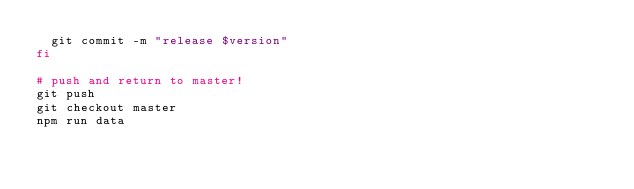Convert code to text. <code><loc_0><loc_0><loc_500><loc_500><_Bash_>  git commit -m "release $version"
fi

# push and return to master!
git push
git checkout master
npm run data
</code> 